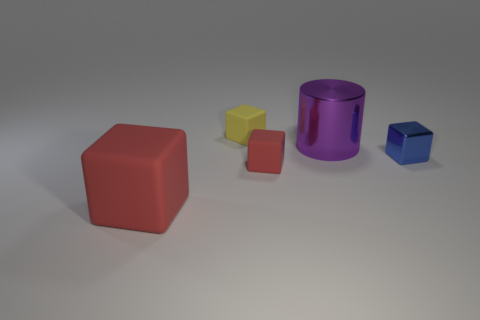Subtract all brown cubes. Subtract all cyan balls. How many cubes are left? 4 Add 1 tiny blue shiny cubes. How many objects exist? 6 Subtract all cubes. How many objects are left? 1 Subtract 0 cyan cylinders. How many objects are left? 5 Subtract all cyan metal cylinders. Subtract all metal objects. How many objects are left? 3 Add 1 tiny yellow cubes. How many tiny yellow cubes are left? 2 Add 5 big metallic objects. How many big metallic objects exist? 6 